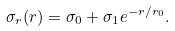Convert formula to latex. <formula><loc_0><loc_0><loc_500><loc_500>\sigma _ { r } ( r ) = \sigma _ { 0 } + \sigma _ { 1 } e ^ { - r / r _ { 0 } } .</formula> 